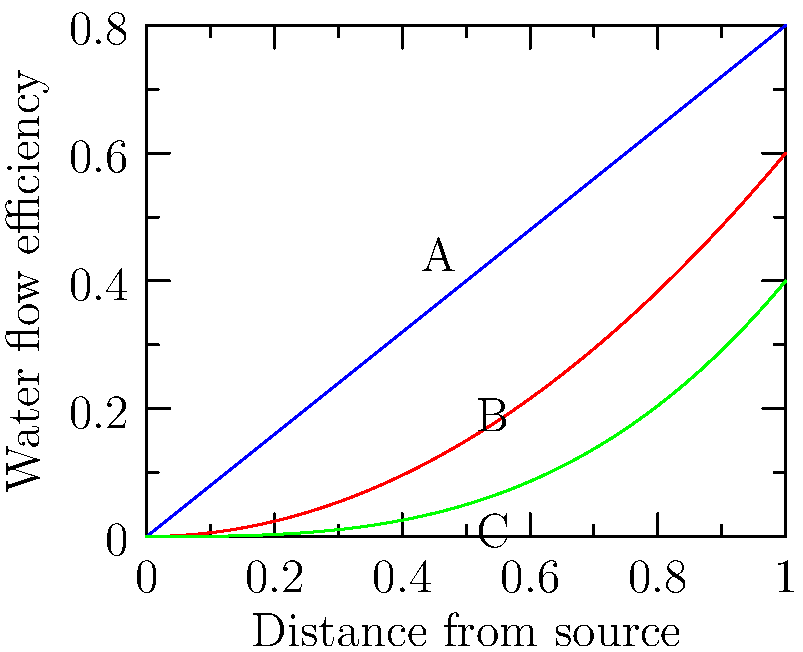In this topological comparison of Roman aqueduct efficiency, which type of aqueduct (represented by A, B, or C) would be most suitable for maintaining consistent water flow over long distances, and why? To determine which aqueduct type is most suitable for maintaining consistent water flow over long distances, we need to analyze the curves representing each type:

1. Curve A (Linear): This represents a linear decrease in efficiency. The water flow decreases at a constant rate as the distance increases.

2. Curve B (Quadratic): This shows a more rapid decrease in efficiency, especially at longer distances. The rate of efficiency loss accelerates as distance increases.

3. Curve C (Cubic): This curve has the slowest initial decrease in efficiency but drops more sharply at longer distances.

For maintaining consistent water flow over long distances:

1. We want a curve that maintains higher efficiency for as long as possible.
2. The curve should have a gradual, rather than steep, decline.

Comparing the curves:
- Curve A maintains the highest efficiency across all distances.
- Curve B and C start higher but drop below A as distance increases.
- Curve A has the most gradual and consistent decline.

Therefore, the aqueduct type represented by Curve A (linear efficiency decrease) would be most suitable for maintaining consistent water flow over long distances. This type of aqueduct would provide the most reliable and steady water supply to distant locations in the Roman Empire.
Answer: A (Linear efficiency decrease) 